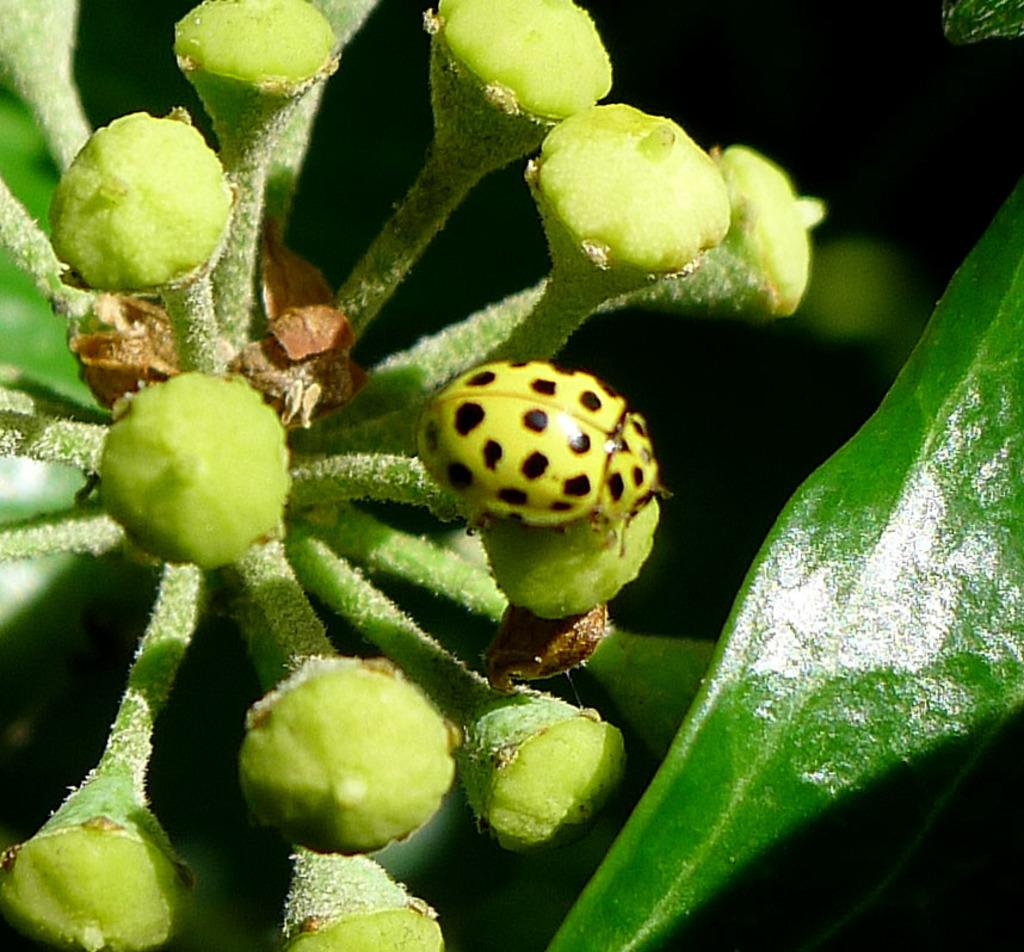What is the main subject of the image? There is a bug in the image. Where is the bug located? The bug is on a plant. Can you describe the position of the bug in the image? The bug is located in the center of the image. What verse is the bug reciting in the image? There is no indication in the image that the bug is reciting a verse, as bugs do not have the ability to speak or recite poetry. 